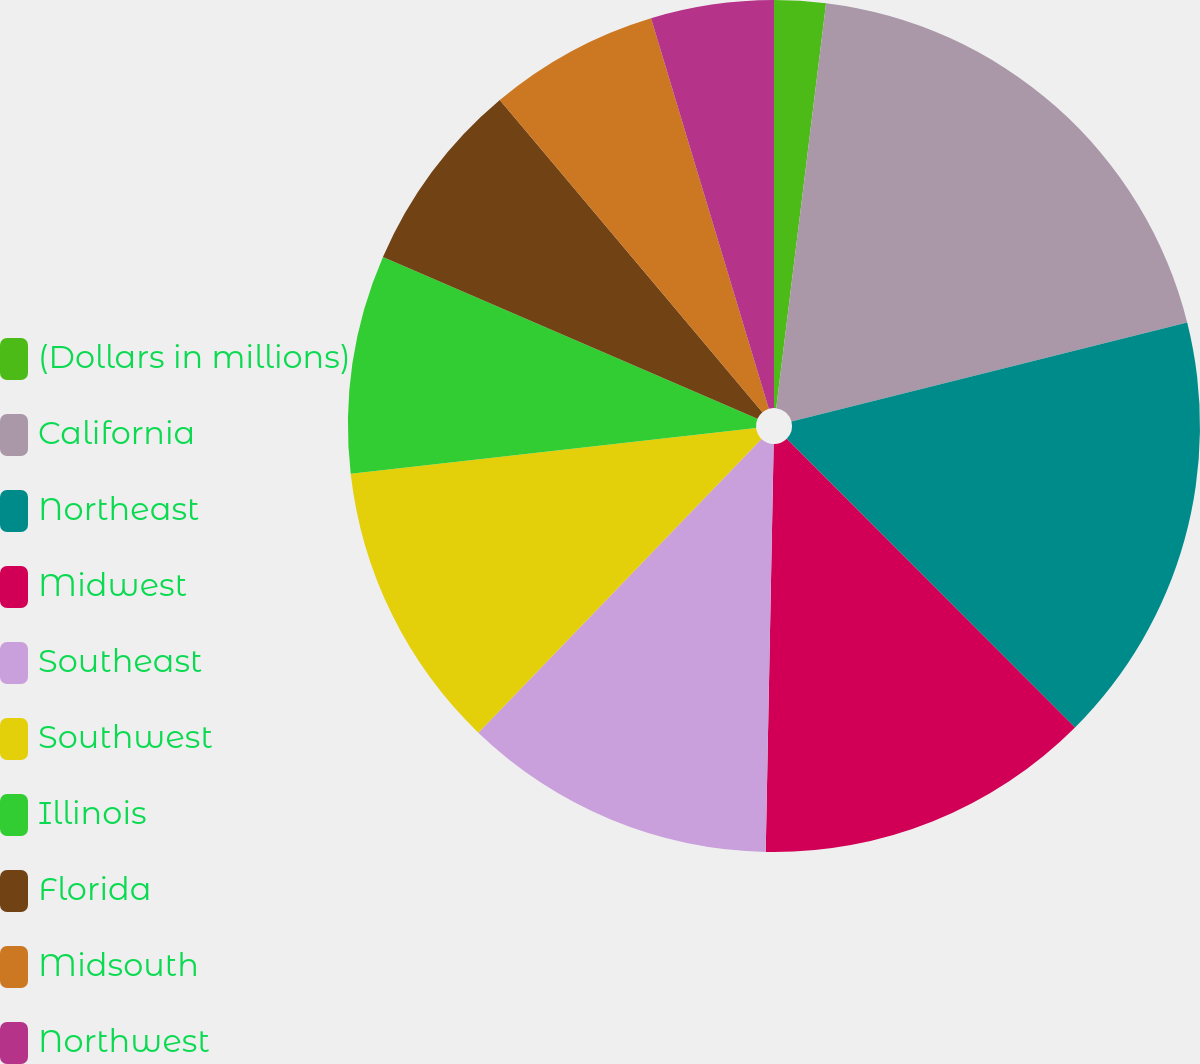<chart> <loc_0><loc_0><loc_500><loc_500><pie_chart><fcel>(Dollars in millions)<fcel>California<fcel>Northeast<fcel>Midwest<fcel>Southeast<fcel>Southwest<fcel>Illinois<fcel>Florida<fcel>Midsouth<fcel>Northwest<nl><fcel>1.95%<fcel>19.14%<fcel>16.42%<fcel>12.8%<fcel>11.9%<fcel>11.0%<fcel>8.28%<fcel>7.38%<fcel>6.47%<fcel>4.66%<nl></chart> 